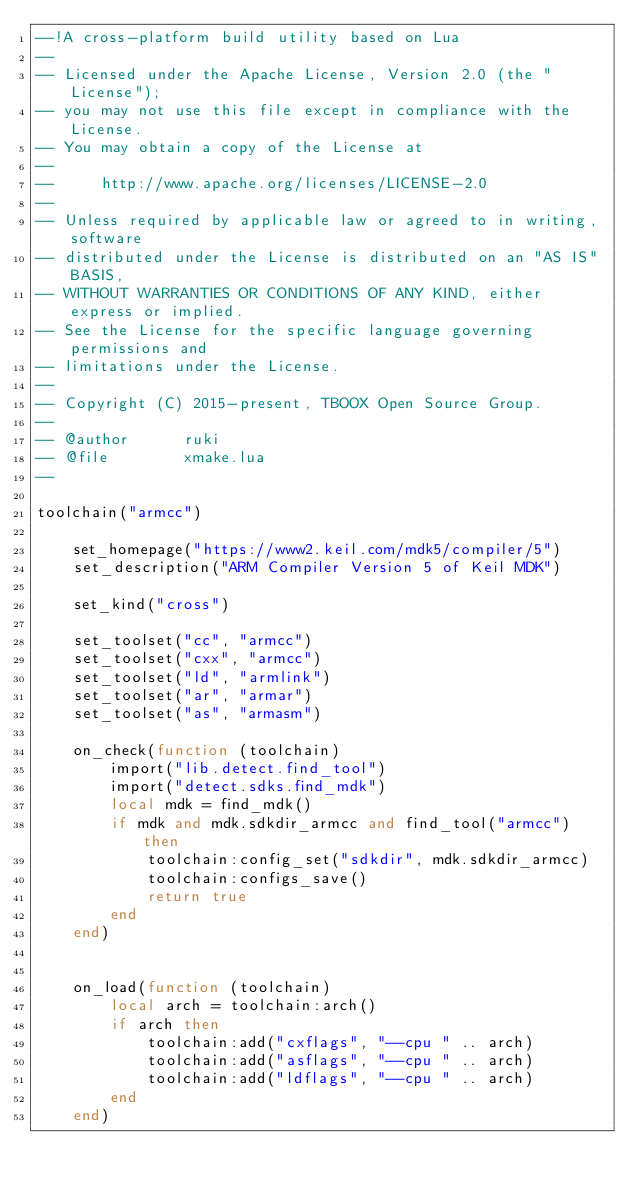<code> <loc_0><loc_0><loc_500><loc_500><_Lua_>--!A cross-platform build utility based on Lua
--
-- Licensed under the Apache License, Version 2.0 (the "License");
-- you may not use this file except in compliance with the License.
-- You may obtain a copy of the License at
--
--     http://www.apache.org/licenses/LICENSE-2.0
--
-- Unless required by applicable law or agreed to in writing, software
-- distributed under the License is distributed on an "AS IS" BASIS,
-- WITHOUT WARRANTIES OR CONDITIONS OF ANY KIND, either express or implied.
-- See the License for the specific language governing permissions and
-- limitations under the License.
--
-- Copyright (C) 2015-present, TBOOX Open Source Group.
--
-- @author      ruki
-- @file        xmake.lua
--

toolchain("armcc")

    set_homepage("https://www2.keil.com/mdk5/compiler/5")
    set_description("ARM Compiler Version 5 of Keil MDK")

    set_kind("cross")

    set_toolset("cc", "armcc")
    set_toolset("cxx", "armcc")
    set_toolset("ld", "armlink")
    set_toolset("ar", "armar")
    set_toolset("as", "armasm")

    on_check(function (toolchain)
        import("lib.detect.find_tool")
        import("detect.sdks.find_mdk")
        local mdk = find_mdk()
        if mdk and mdk.sdkdir_armcc and find_tool("armcc") then
            toolchain:config_set("sdkdir", mdk.sdkdir_armcc)
            toolchain:configs_save()
            return true
        end
    end)


    on_load(function (toolchain)
        local arch = toolchain:arch()
        if arch then
            toolchain:add("cxflags", "--cpu " .. arch)
            toolchain:add("asflags", "--cpu " .. arch)
            toolchain:add("ldflags", "--cpu " .. arch)
        end
    end)
</code> 